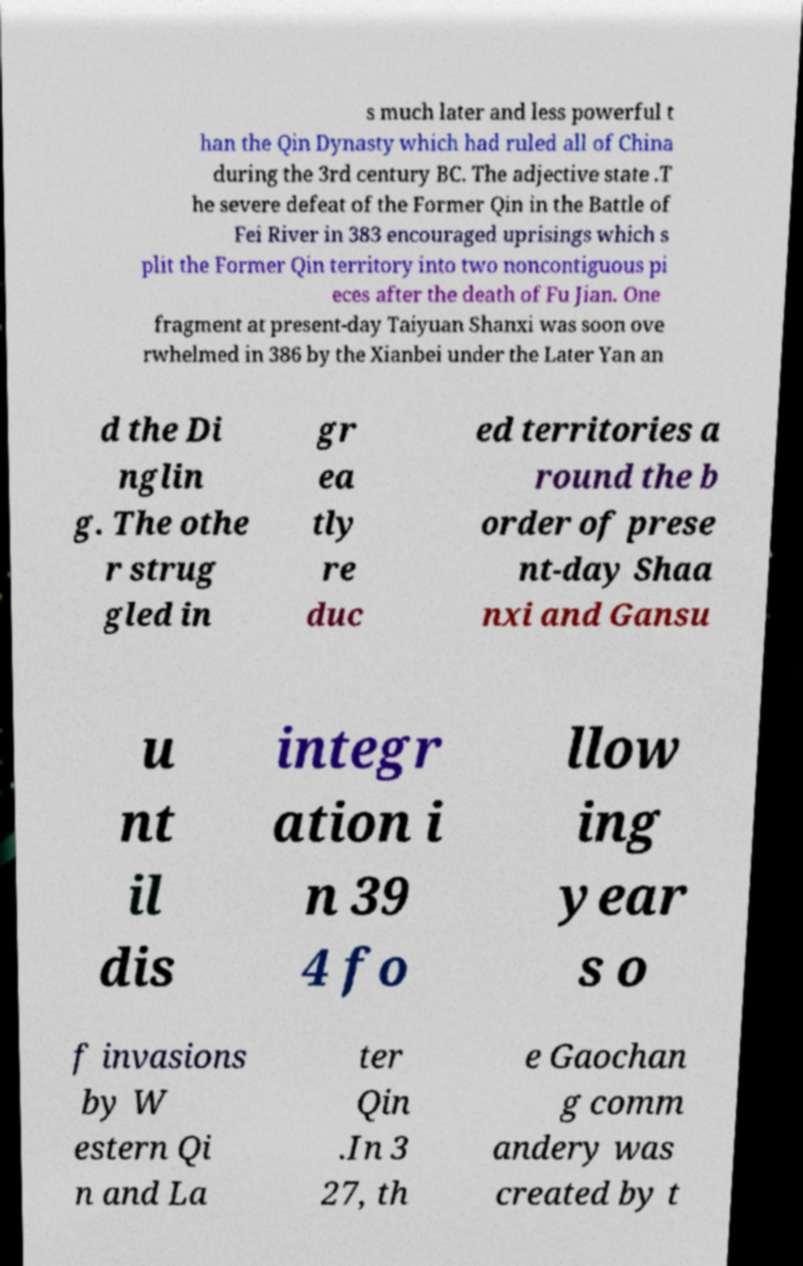What messages or text are displayed in this image? I need them in a readable, typed format. s much later and less powerful t han the Qin Dynasty which had ruled all of China during the 3rd century BC. The adjective state .T he severe defeat of the Former Qin in the Battle of Fei River in 383 encouraged uprisings which s plit the Former Qin territory into two noncontiguous pi eces after the death of Fu Jian. One fragment at present-day Taiyuan Shanxi was soon ove rwhelmed in 386 by the Xianbei under the Later Yan an d the Di nglin g. The othe r strug gled in gr ea tly re duc ed territories a round the b order of prese nt-day Shaa nxi and Gansu u nt il dis integr ation i n 39 4 fo llow ing year s o f invasions by W estern Qi n and La ter Qin .In 3 27, th e Gaochan g comm andery was created by t 